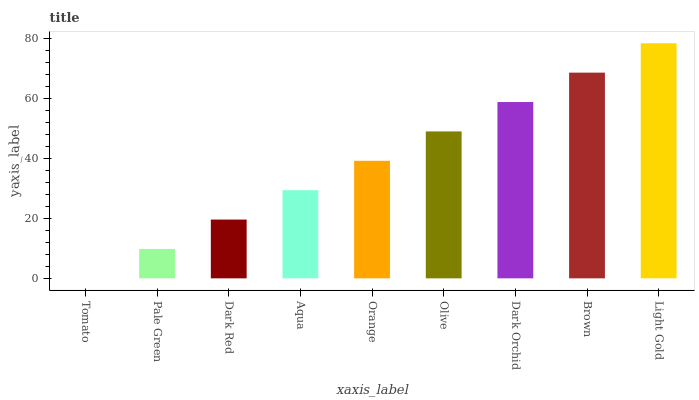Is Tomato the minimum?
Answer yes or no. Yes. Is Light Gold the maximum?
Answer yes or no. Yes. Is Pale Green the minimum?
Answer yes or no. No. Is Pale Green the maximum?
Answer yes or no. No. Is Pale Green greater than Tomato?
Answer yes or no. Yes. Is Tomato less than Pale Green?
Answer yes or no. Yes. Is Tomato greater than Pale Green?
Answer yes or no. No. Is Pale Green less than Tomato?
Answer yes or no. No. Is Orange the high median?
Answer yes or no. Yes. Is Orange the low median?
Answer yes or no. Yes. Is Light Gold the high median?
Answer yes or no. No. Is Light Gold the low median?
Answer yes or no. No. 